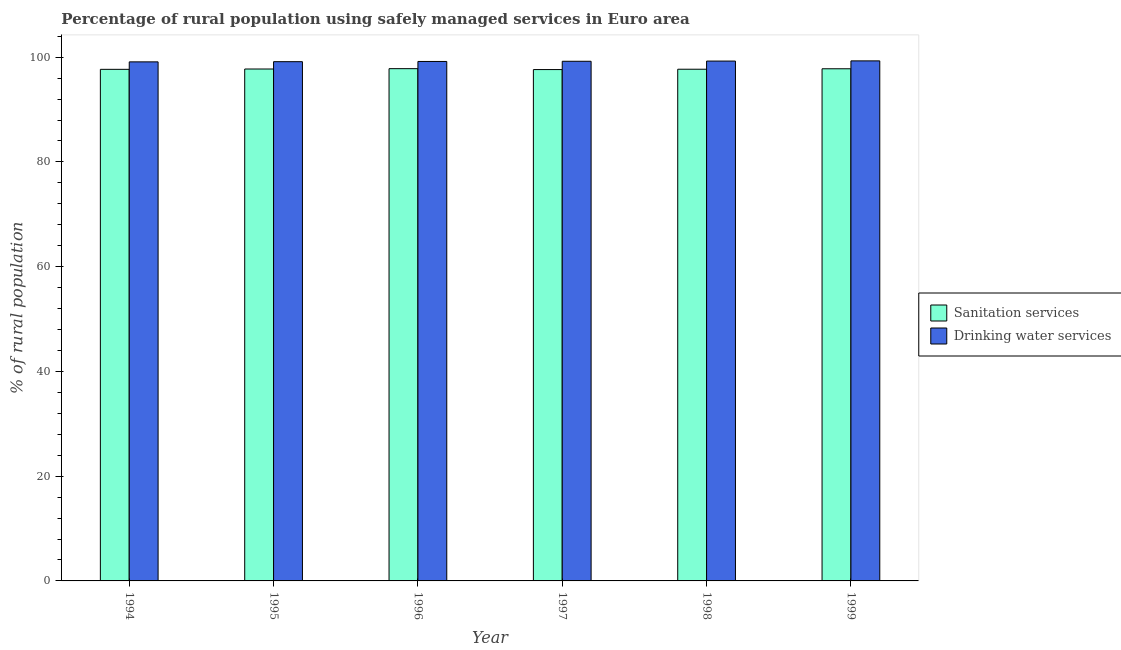Are the number of bars per tick equal to the number of legend labels?
Keep it short and to the point. Yes. How many bars are there on the 5th tick from the left?
Your response must be concise. 2. How many bars are there on the 3rd tick from the right?
Provide a succinct answer. 2. What is the percentage of rural population who used drinking water services in 1997?
Your response must be concise. 99.22. Across all years, what is the maximum percentage of rural population who used drinking water services?
Offer a terse response. 99.29. Across all years, what is the minimum percentage of rural population who used drinking water services?
Offer a very short reply. 99.1. In which year was the percentage of rural population who used sanitation services maximum?
Your answer should be compact. 1996. What is the total percentage of rural population who used sanitation services in the graph?
Your answer should be very brief. 586.32. What is the difference between the percentage of rural population who used drinking water services in 1995 and that in 1996?
Ensure brevity in your answer.  -0.04. What is the difference between the percentage of rural population who used drinking water services in 1997 and the percentage of rural population who used sanitation services in 1995?
Offer a terse response. 0.08. What is the average percentage of rural population who used drinking water services per year?
Your response must be concise. 99.2. In the year 1996, what is the difference between the percentage of rural population who used drinking water services and percentage of rural population who used sanitation services?
Your answer should be very brief. 0. In how many years, is the percentage of rural population who used drinking water services greater than 40 %?
Your answer should be very brief. 6. What is the ratio of the percentage of rural population who used sanitation services in 1995 to that in 1999?
Your answer should be very brief. 1. Is the difference between the percentage of rural population who used drinking water services in 1995 and 1996 greater than the difference between the percentage of rural population who used sanitation services in 1995 and 1996?
Give a very brief answer. No. What is the difference between the highest and the second highest percentage of rural population who used sanitation services?
Provide a short and direct response. 0.02. What is the difference between the highest and the lowest percentage of rural population who used drinking water services?
Offer a terse response. 0.19. In how many years, is the percentage of rural population who used sanitation services greater than the average percentage of rural population who used sanitation services taken over all years?
Your answer should be compact. 3. Is the sum of the percentage of rural population who used drinking water services in 1995 and 1996 greater than the maximum percentage of rural population who used sanitation services across all years?
Ensure brevity in your answer.  Yes. What does the 2nd bar from the left in 1996 represents?
Ensure brevity in your answer.  Drinking water services. What does the 2nd bar from the right in 1995 represents?
Your answer should be very brief. Sanitation services. How many bars are there?
Provide a succinct answer. 12. Are all the bars in the graph horizontal?
Offer a terse response. No. How many years are there in the graph?
Your response must be concise. 6. Does the graph contain grids?
Give a very brief answer. No. What is the title of the graph?
Provide a succinct answer. Percentage of rural population using safely managed services in Euro area. What is the label or title of the X-axis?
Make the answer very short. Year. What is the label or title of the Y-axis?
Your response must be concise. % of rural population. What is the % of rural population of Sanitation services in 1994?
Offer a terse response. 97.67. What is the % of rural population in Drinking water services in 1994?
Offer a very short reply. 99.1. What is the % of rural population in Sanitation services in 1995?
Provide a short and direct response. 97.74. What is the % of rural population of Drinking water services in 1995?
Keep it short and to the point. 99.14. What is the % of rural population of Sanitation services in 1996?
Make the answer very short. 97.8. What is the % of rural population in Drinking water services in 1996?
Keep it short and to the point. 99.18. What is the % of rural population of Sanitation services in 1997?
Offer a very short reply. 97.63. What is the % of rural population in Drinking water services in 1997?
Offer a terse response. 99.22. What is the % of rural population in Sanitation services in 1998?
Your answer should be compact. 97.69. What is the % of rural population of Drinking water services in 1998?
Offer a terse response. 99.25. What is the % of rural population in Sanitation services in 1999?
Your response must be concise. 97.78. What is the % of rural population of Drinking water services in 1999?
Keep it short and to the point. 99.29. Across all years, what is the maximum % of rural population in Sanitation services?
Provide a short and direct response. 97.8. Across all years, what is the maximum % of rural population of Drinking water services?
Your answer should be compact. 99.29. Across all years, what is the minimum % of rural population in Sanitation services?
Offer a terse response. 97.63. Across all years, what is the minimum % of rural population of Drinking water services?
Keep it short and to the point. 99.1. What is the total % of rural population of Sanitation services in the graph?
Give a very brief answer. 586.32. What is the total % of rural population of Drinking water services in the graph?
Provide a short and direct response. 595.17. What is the difference between the % of rural population of Sanitation services in 1994 and that in 1995?
Provide a short and direct response. -0.06. What is the difference between the % of rural population in Drinking water services in 1994 and that in 1995?
Your response must be concise. -0.03. What is the difference between the % of rural population of Sanitation services in 1994 and that in 1996?
Your response must be concise. -0.13. What is the difference between the % of rural population of Drinking water services in 1994 and that in 1996?
Your answer should be very brief. -0.08. What is the difference between the % of rural population of Sanitation services in 1994 and that in 1997?
Provide a succinct answer. 0.04. What is the difference between the % of rural population in Drinking water services in 1994 and that in 1997?
Your answer should be compact. -0.11. What is the difference between the % of rural population in Sanitation services in 1994 and that in 1998?
Provide a succinct answer. -0.02. What is the difference between the % of rural population of Drinking water services in 1994 and that in 1998?
Give a very brief answer. -0.15. What is the difference between the % of rural population in Sanitation services in 1994 and that in 1999?
Your response must be concise. -0.11. What is the difference between the % of rural population in Drinking water services in 1994 and that in 1999?
Provide a succinct answer. -0.19. What is the difference between the % of rural population in Sanitation services in 1995 and that in 1996?
Keep it short and to the point. -0.07. What is the difference between the % of rural population of Drinking water services in 1995 and that in 1996?
Give a very brief answer. -0.04. What is the difference between the % of rural population of Sanitation services in 1995 and that in 1997?
Your response must be concise. 0.11. What is the difference between the % of rural population in Drinking water services in 1995 and that in 1997?
Provide a short and direct response. -0.08. What is the difference between the % of rural population in Sanitation services in 1995 and that in 1998?
Ensure brevity in your answer.  0.04. What is the difference between the % of rural population in Drinking water services in 1995 and that in 1998?
Offer a terse response. -0.12. What is the difference between the % of rural population of Sanitation services in 1995 and that in 1999?
Offer a very short reply. -0.04. What is the difference between the % of rural population in Drinking water services in 1995 and that in 1999?
Make the answer very short. -0.15. What is the difference between the % of rural population in Sanitation services in 1996 and that in 1997?
Ensure brevity in your answer.  0.17. What is the difference between the % of rural population of Drinking water services in 1996 and that in 1997?
Your answer should be compact. -0.04. What is the difference between the % of rural population of Sanitation services in 1996 and that in 1998?
Provide a short and direct response. 0.11. What is the difference between the % of rural population in Drinking water services in 1996 and that in 1998?
Provide a short and direct response. -0.07. What is the difference between the % of rural population of Sanitation services in 1996 and that in 1999?
Make the answer very short. 0.02. What is the difference between the % of rural population of Drinking water services in 1996 and that in 1999?
Make the answer very short. -0.11. What is the difference between the % of rural population of Sanitation services in 1997 and that in 1998?
Your answer should be very brief. -0.06. What is the difference between the % of rural population of Drinking water services in 1997 and that in 1998?
Your answer should be very brief. -0.04. What is the difference between the % of rural population of Sanitation services in 1997 and that in 1999?
Give a very brief answer. -0.15. What is the difference between the % of rural population in Drinking water services in 1997 and that in 1999?
Give a very brief answer. -0.07. What is the difference between the % of rural population in Sanitation services in 1998 and that in 1999?
Offer a terse response. -0.09. What is the difference between the % of rural population in Drinking water services in 1998 and that in 1999?
Offer a very short reply. -0.04. What is the difference between the % of rural population of Sanitation services in 1994 and the % of rural population of Drinking water services in 1995?
Give a very brief answer. -1.46. What is the difference between the % of rural population in Sanitation services in 1994 and the % of rural population in Drinking water services in 1996?
Your response must be concise. -1.5. What is the difference between the % of rural population in Sanitation services in 1994 and the % of rural population in Drinking water services in 1997?
Offer a terse response. -1.54. What is the difference between the % of rural population of Sanitation services in 1994 and the % of rural population of Drinking water services in 1998?
Ensure brevity in your answer.  -1.58. What is the difference between the % of rural population in Sanitation services in 1994 and the % of rural population in Drinking water services in 1999?
Your answer should be very brief. -1.62. What is the difference between the % of rural population of Sanitation services in 1995 and the % of rural population of Drinking water services in 1996?
Provide a short and direct response. -1.44. What is the difference between the % of rural population of Sanitation services in 1995 and the % of rural population of Drinking water services in 1997?
Keep it short and to the point. -1.48. What is the difference between the % of rural population in Sanitation services in 1995 and the % of rural population in Drinking water services in 1998?
Provide a succinct answer. -1.52. What is the difference between the % of rural population of Sanitation services in 1995 and the % of rural population of Drinking water services in 1999?
Keep it short and to the point. -1.55. What is the difference between the % of rural population of Sanitation services in 1996 and the % of rural population of Drinking water services in 1997?
Your answer should be very brief. -1.41. What is the difference between the % of rural population of Sanitation services in 1996 and the % of rural population of Drinking water services in 1998?
Your answer should be compact. -1.45. What is the difference between the % of rural population of Sanitation services in 1996 and the % of rural population of Drinking water services in 1999?
Give a very brief answer. -1.49. What is the difference between the % of rural population of Sanitation services in 1997 and the % of rural population of Drinking water services in 1998?
Provide a succinct answer. -1.62. What is the difference between the % of rural population of Sanitation services in 1997 and the % of rural population of Drinking water services in 1999?
Your response must be concise. -1.66. What is the difference between the % of rural population of Sanitation services in 1998 and the % of rural population of Drinking water services in 1999?
Your answer should be very brief. -1.6. What is the average % of rural population in Sanitation services per year?
Your answer should be compact. 97.72. What is the average % of rural population in Drinking water services per year?
Your response must be concise. 99.2. In the year 1994, what is the difference between the % of rural population of Sanitation services and % of rural population of Drinking water services?
Provide a succinct answer. -1.43. In the year 1995, what is the difference between the % of rural population in Sanitation services and % of rural population in Drinking water services?
Offer a very short reply. -1.4. In the year 1996, what is the difference between the % of rural population of Sanitation services and % of rural population of Drinking water services?
Your response must be concise. -1.37. In the year 1997, what is the difference between the % of rural population in Sanitation services and % of rural population in Drinking water services?
Keep it short and to the point. -1.58. In the year 1998, what is the difference between the % of rural population in Sanitation services and % of rural population in Drinking water services?
Offer a very short reply. -1.56. In the year 1999, what is the difference between the % of rural population in Sanitation services and % of rural population in Drinking water services?
Ensure brevity in your answer.  -1.51. What is the ratio of the % of rural population in Sanitation services in 1994 to that in 1995?
Give a very brief answer. 1. What is the ratio of the % of rural population in Sanitation services in 1994 to that in 1996?
Provide a succinct answer. 1. What is the ratio of the % of rural population of Sanitation services in 1994 to that in 1997?
Your response must be concise. 1. What is the ratio of the % of rural population of Drinking water services in 1994 to that in 1997?
Your answer should be compact. 1. What is the ratio of the % of rural population of Sanitation services in 1994 to that in 1998?
Ensure brevity in your answer.  1. What is the ratio of the % of rural population in Drinking water services in 1994 to that in 1998?
Provide a short and direct response. 1. What is the ratio of the % of rural population in Sanitation services in 1994 to that in 1999?
Provide a succinct answer. 1. What is the ratio of the % of rural population of Sanitation services in 1995 to that in 1996?
Provide a succinct answer. 1. What is the ratio of the % of rural population in Drinking water services in 1995 to that in 1996?
Offer a very short reply. 1. What is the ratio of the % of rural population in Drinking water services in 1995 to that in 1997?
Provide a succinct answer. 1. What is the ratio of the % of rural population in Drinking water services in 1995 to that in 1998?
Make the answer very short. 1. What is the ratio of the % of rural population of Drinking water services in 1995 to that in 1999?
Provide a short and direct response. 1. What is the ratio of the % of rural population of Drinking water services in 1996 to that in 1997?
Your response must be concise. 1. What is the ratio of the % of rural population of Sanitation services in 1996 to that in 1998?
Provide a succinct answer. 1. What is the ratio of the % of rural population in Sanitation services in 1996 to that in 1999?
Your answer should be compact. 1. What is the ratio of the % of rural population in Drinking water services in 1996 to that in 1999?
Keep it short and to the point. 1. What is the ratio of the % of rural population in Sanitation services in 1997 to that in 1998?
Give a very brief answer. 1. What is the ratio of the % of rural population in Sanitation services in 1997 to that in 1999?
Ensure brevity in your answer.  1. What is the ratio of the % of rural population in Drinking water services in 1997 to that in 1999?
Give a very brief answer. 1. What is the ratio of the % of rural population of Sanitation services in 1998 to that in 1999?
Keep it short and to the point. 1. What is the ratio of the % of rural population in Drinking water services in 1998 to that in 1999?
Provide a succinct answer. 1. What is the difference between the highest and the second highest % of rural population of Sanitation services?
Provide a succinct answer. 0.02. What is the difference between the highest and the second highest % of rural population of Drinking water services?
Provide a short and direct response. 0.04. What is the difference between the highest and the lowest % of rural population in Sanitation services?
Provide a short and direct response. 0.17. What is the difference between the highest and the lowest % of rural population in Drinking water services?
Keep it short and to the point. 0.19. 